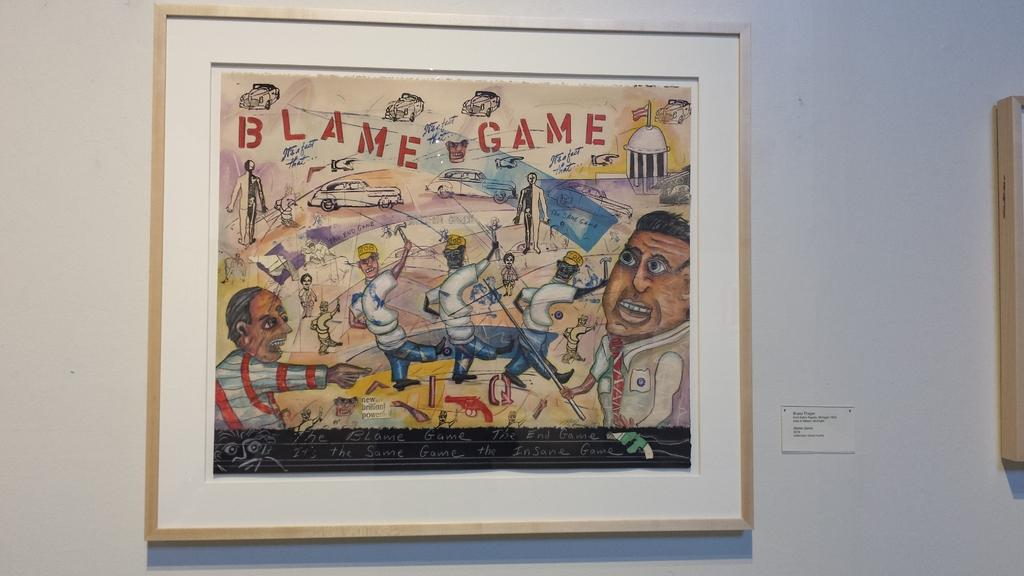<image>
Describe the image concisely. a framed art work with words Blame Game on it 